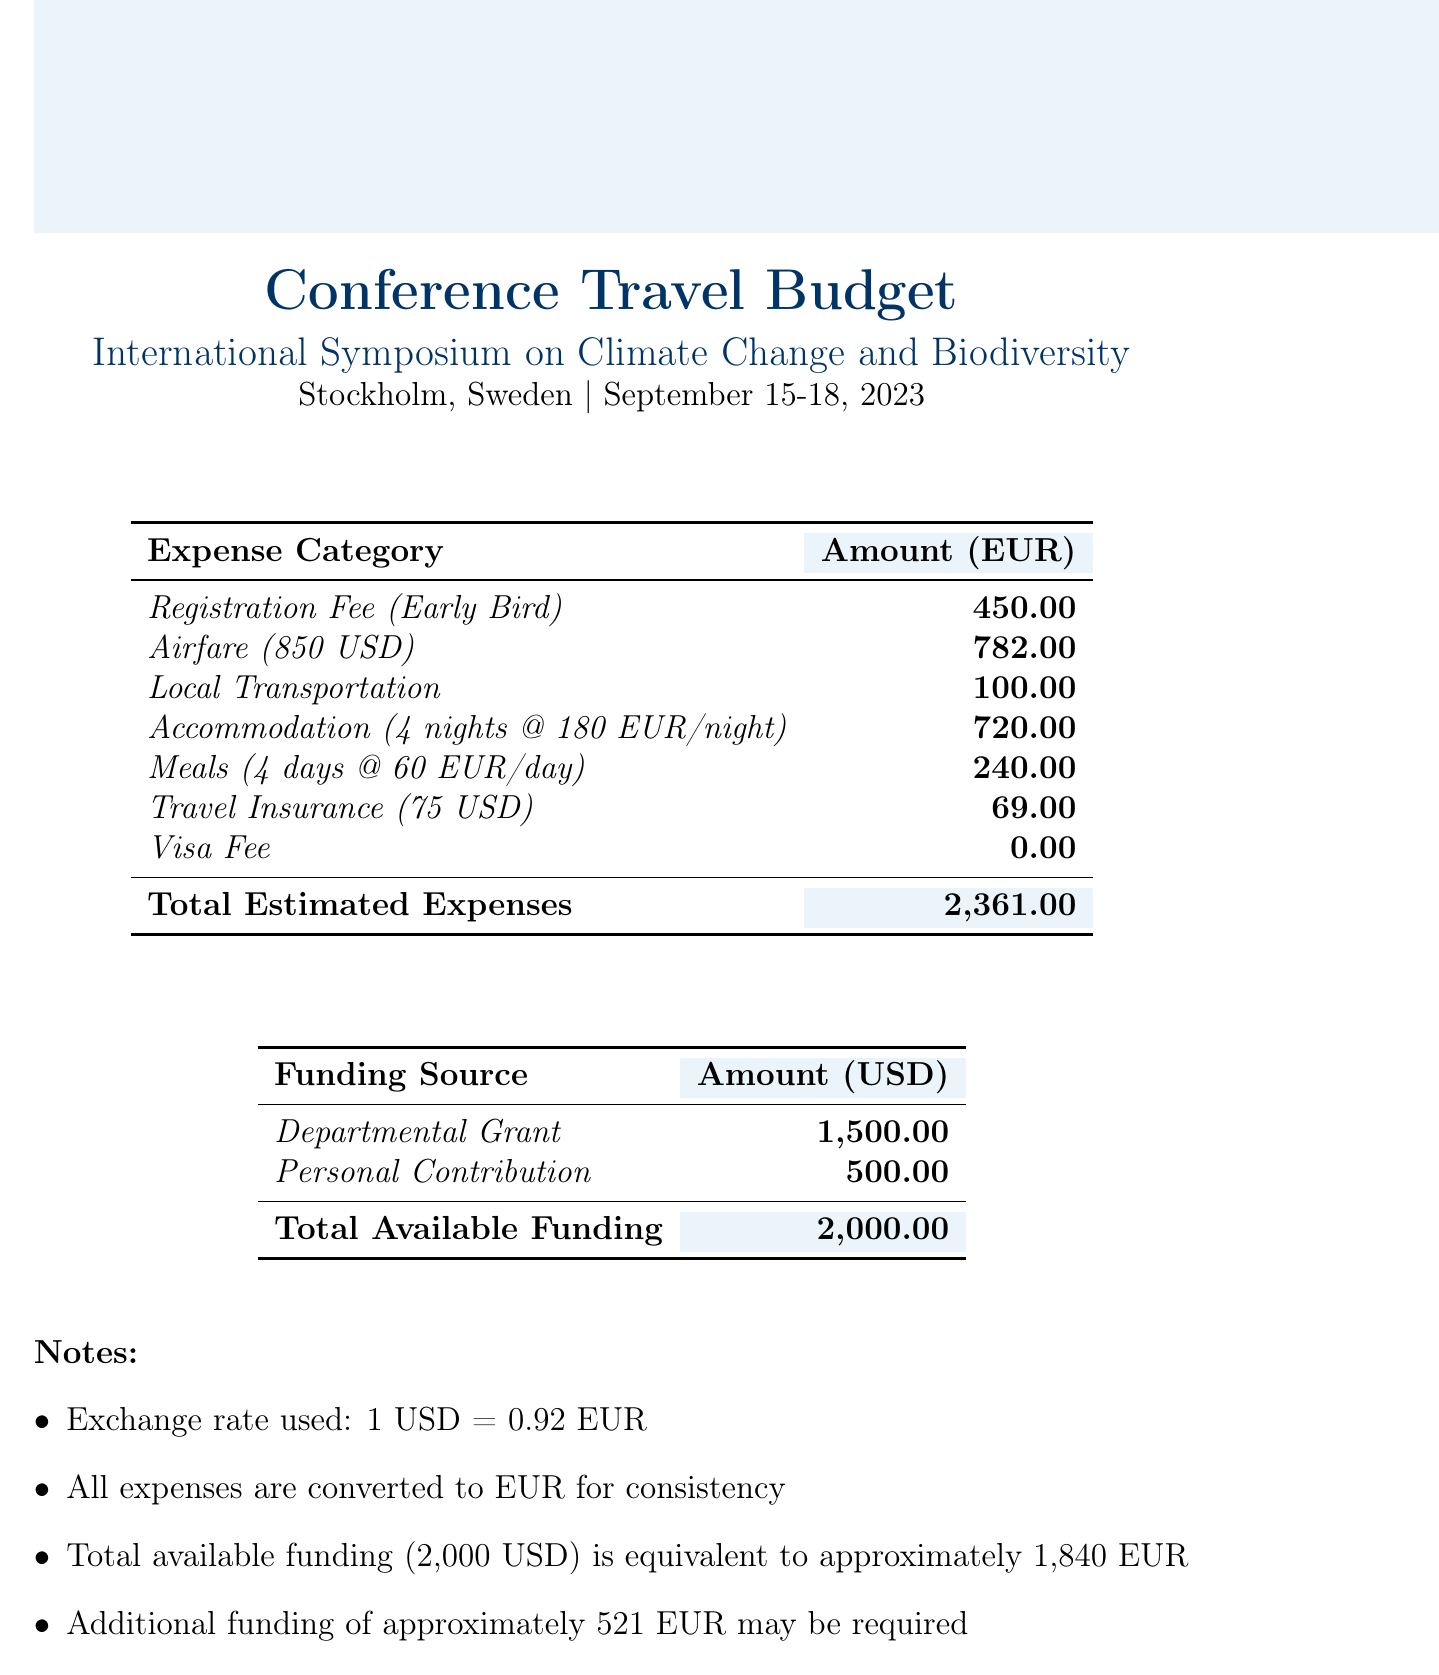what is the total estimated expense? The total estimated expenses are calculated by summing all the expense categories listed in the document.
Answer: 2,361.00 how much is the registration fee? The registration fee is clearly stated as an expense category in the budget.
Answer: 450.00 what is the airfare cost in euros? The airfare is listed as 850 USD, which has been converted into EUR for the budget.
Answer: 782.00 how many nights of accommodation are accounted for? The budget specifies the accommodation based on a rate per night over a specified number of nights.
Answer: 4 what is the total available funding in euros? The total available funding is derived from converting the available funding amount from USD to EUR as mentioned in the notes.
Answer: 1,840 EUR how much local transportation is budgeted? The budget explicitly states the local transportation cost as a line item.
Answer: 100.00 how much additional funding may be required? The document notes the potential additional funding that may be necessary, calculated from the total expenses and available funding.
Answer: approximately 521 EUR what is the funding source that contributes the most? The budget outlines two funding sources, and the one with the higher amount can be identified.
Answer: Departmental Grant what are the meals budgeted per day? The document lists the total amount budgeted for meals, which is divided by the number of days for the calculation.
Answer: 60 EUR/day what is the currency exchange rate used? The notes provide the exchange rate that was applied to convert USD to EUR in the document.
Answer: 1 USD = 0.92 EUR 